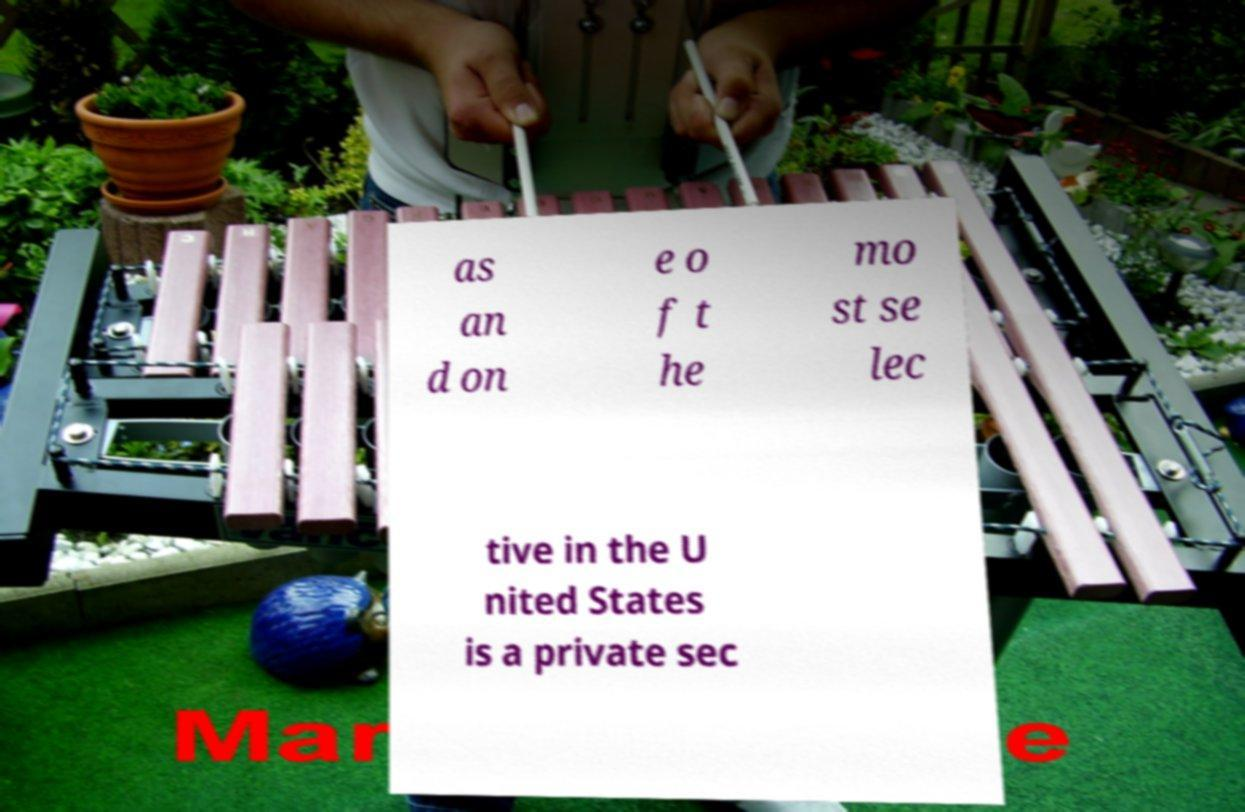I need the written content from this picture converted into text. Can you do that? as an d on e o f t he mo st se lec tive in the U nited States is a private sec 